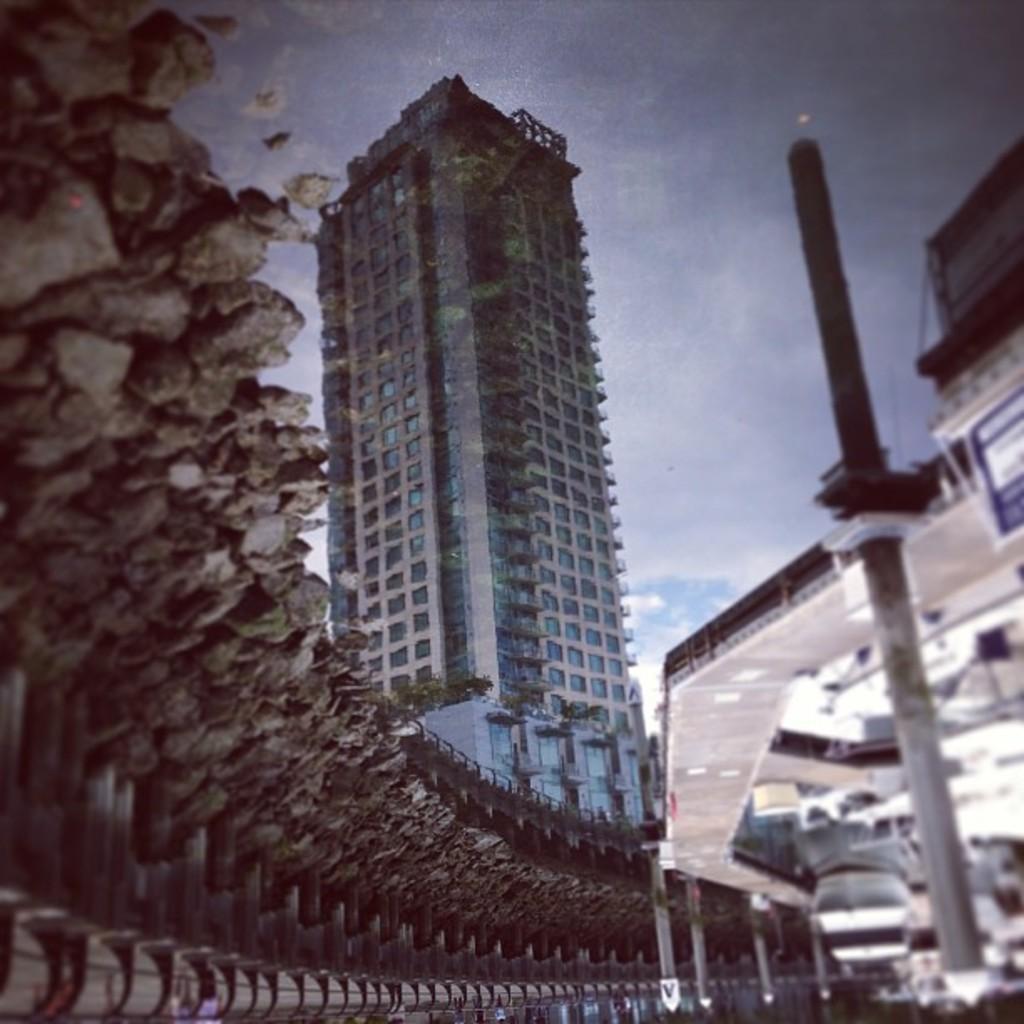Please provide a concise description of this image. In this picture we can see stones, bridges, vehicle, poles, trees, buildings and some objects. In the background we can see the sky. 